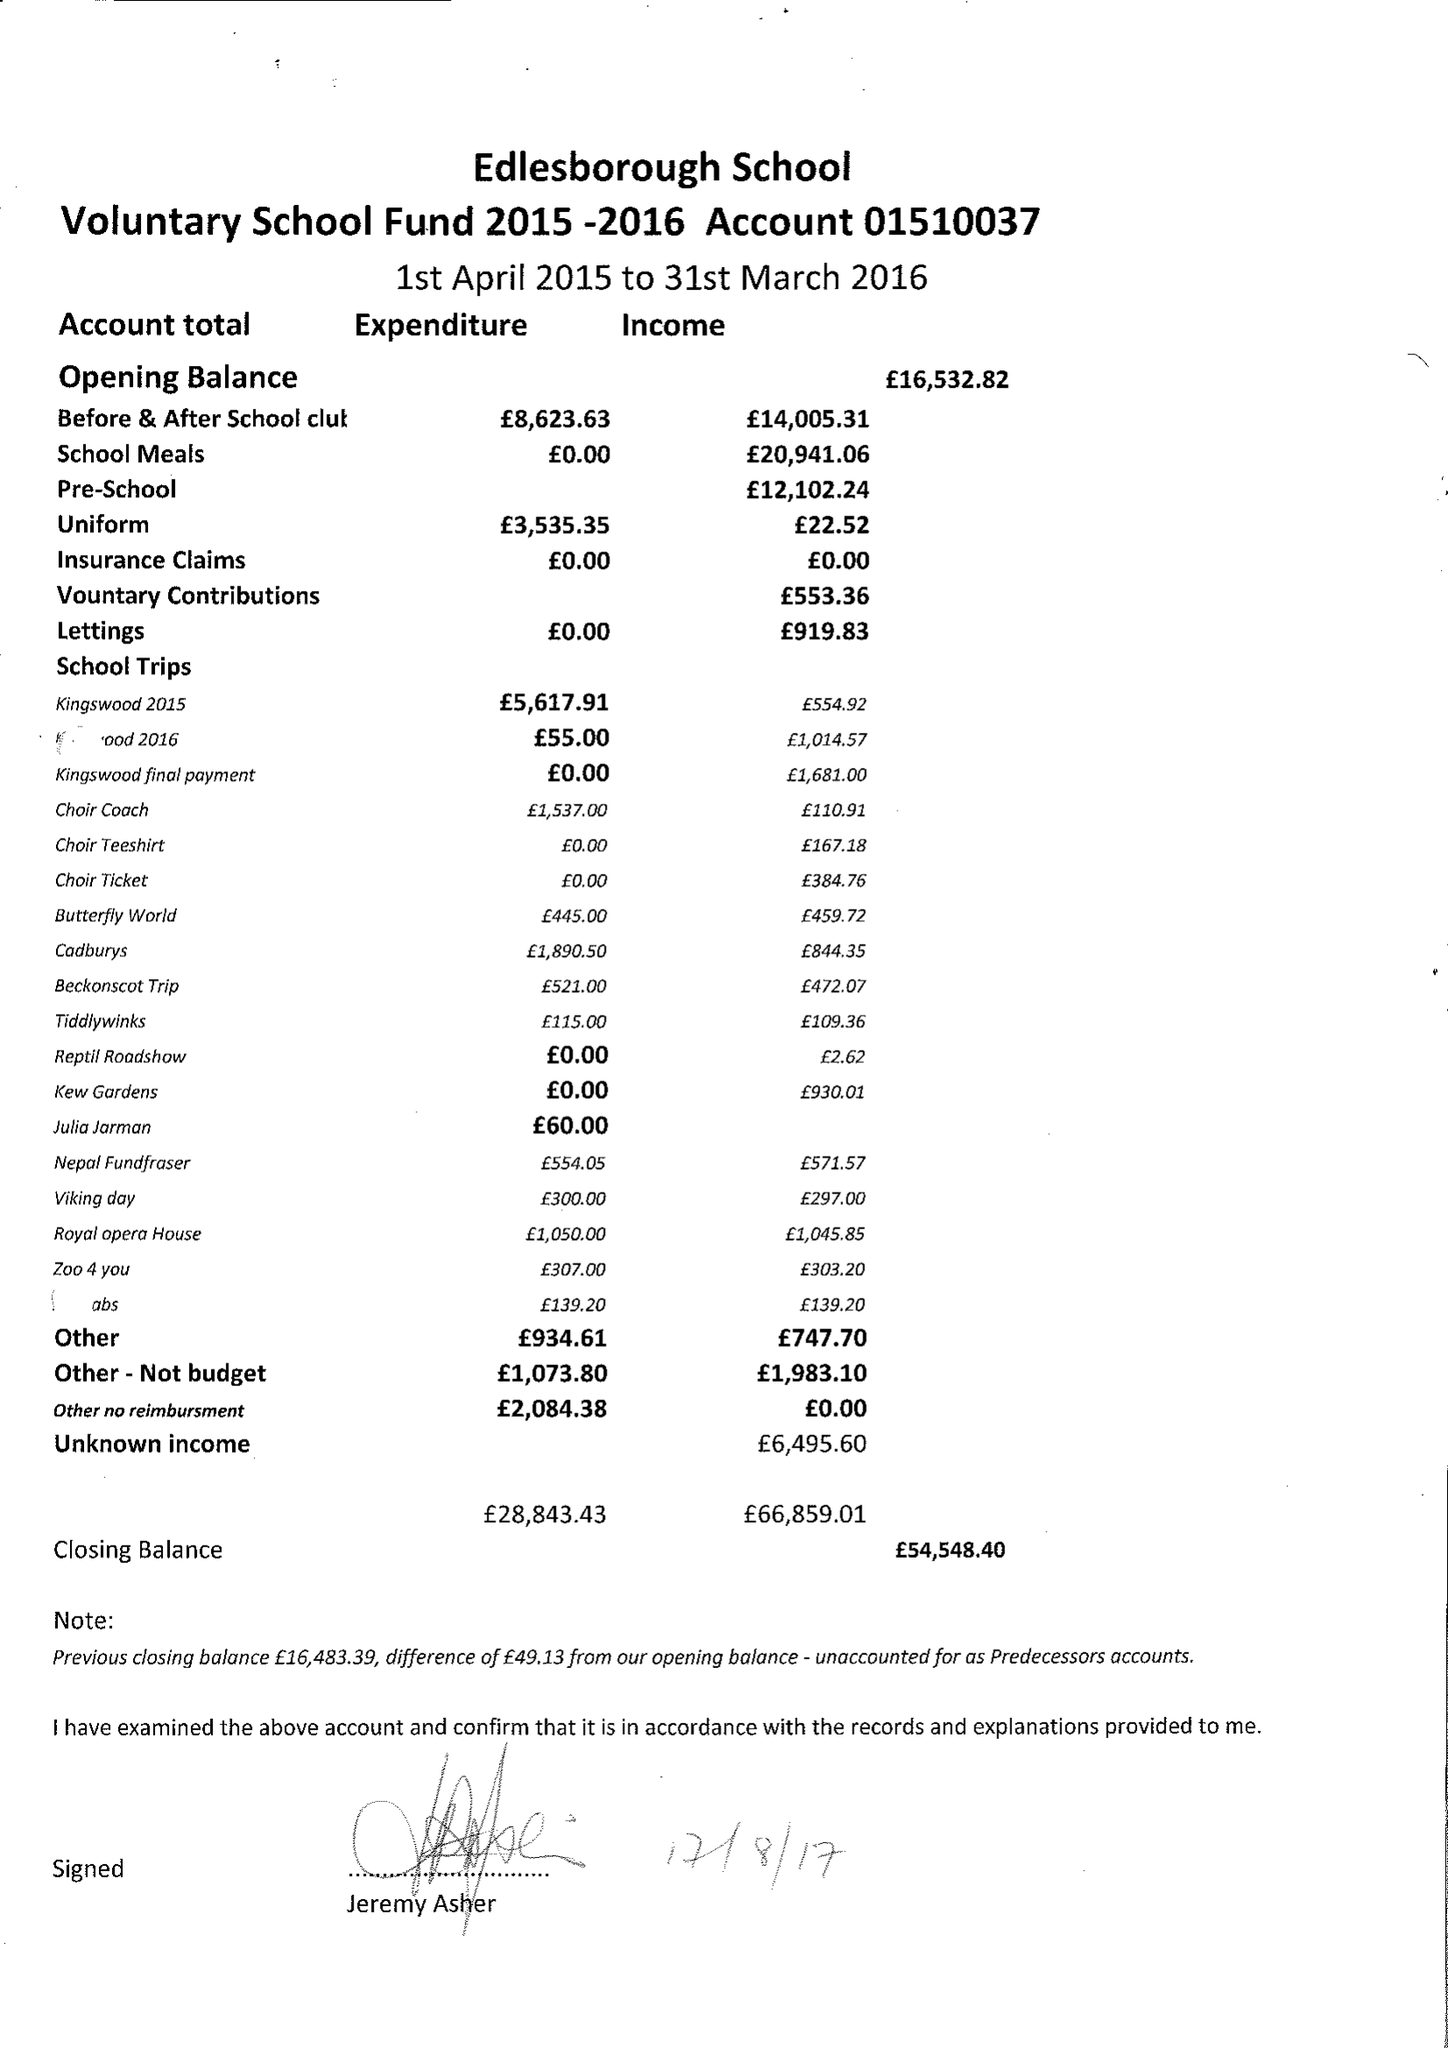What is the value for the address__post_town?
Answer the question using a single word or phrase. DUNSTABLE 